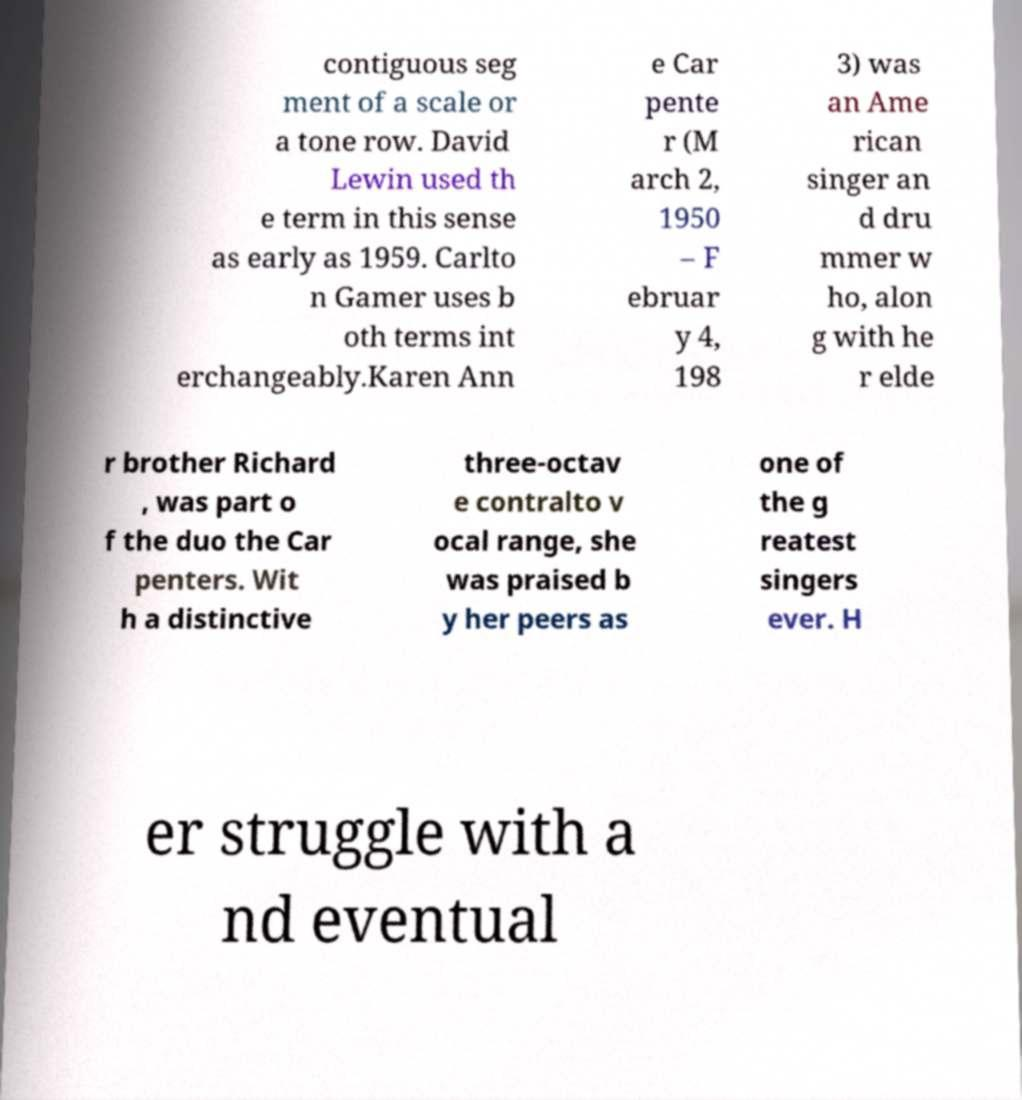I need the written content from this picture converted into text. Can you do that? contiguous seg ment of a scale or a tone row. David Lewin used th e term in this sense as early as 1959. Carlto n Gamer uses b oth terms int erchangeably.Karen Ann e Car pente r (M arch 2, 1950 – F ebruar y 4, 198 3) was an Ame rican singer an d dru mmer w ho, alon g with he r elde r brother Richard , was part o f the duo the Car penters. Wit h a distinctive three-octav e contralto v ocal range, she was praised b y her peers as one of the g reatest singers ever. H er struggle with a nd eventual 